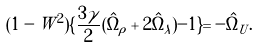<formula> <loc_0><loc_0><loc_500><loc_500>( 1 - W ^ { 2 } ) \{ \frac { 3 \gamma } { 2 } ( \hat { \Omega } _ { \rho } + 2 \hat { \Omega } _ { \lambda } ) - 1 \} = - \hat { \Omega } _ { U } .</formula> 